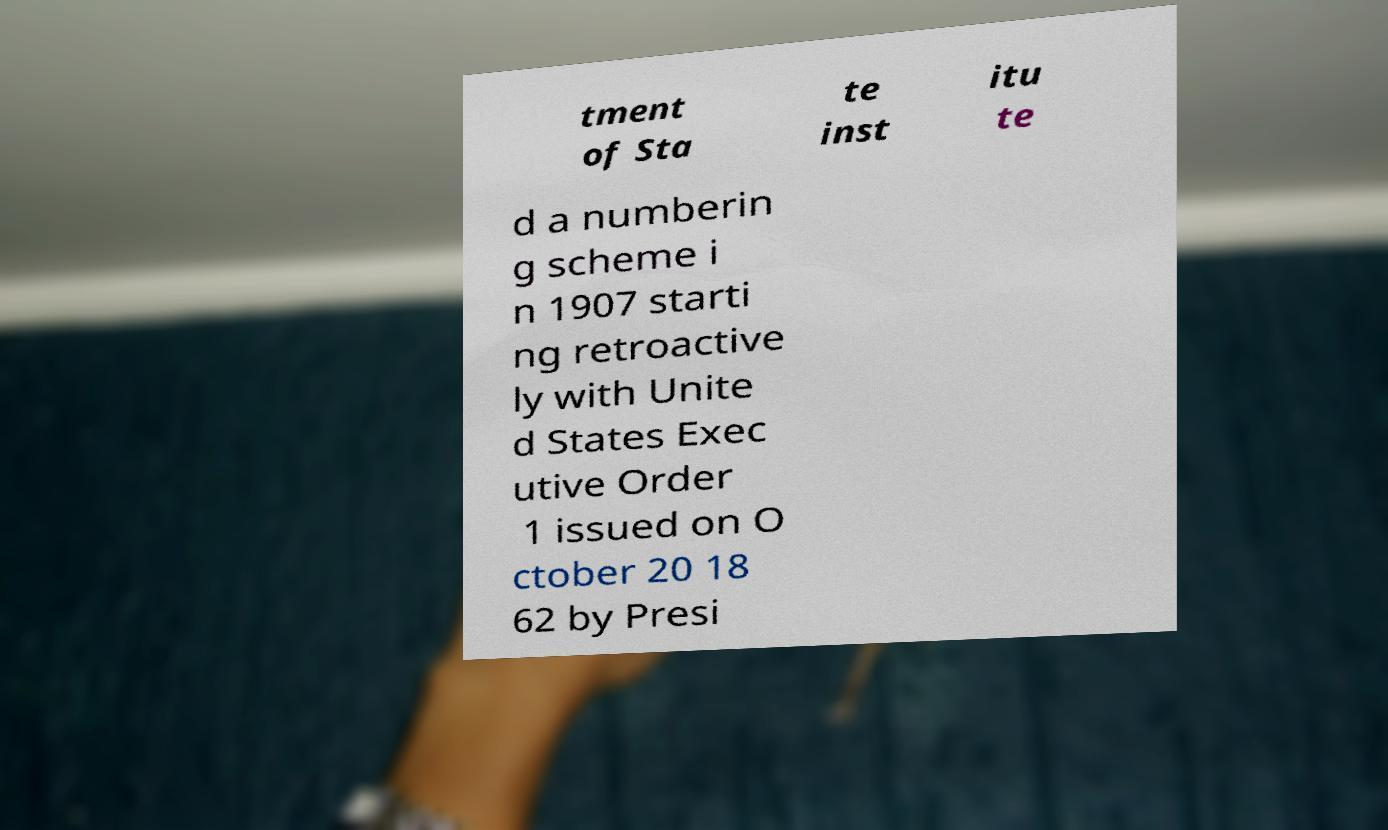There's text embedded in this image that I need extracted. Can you transcribe it verbatim? tment of Sta te inst itu te d a numberin g scheme i n 1907 starti ng retroactive ly with Unite d States Exec utive Order 1 issued on O ctober 20 18 62 by Presi 